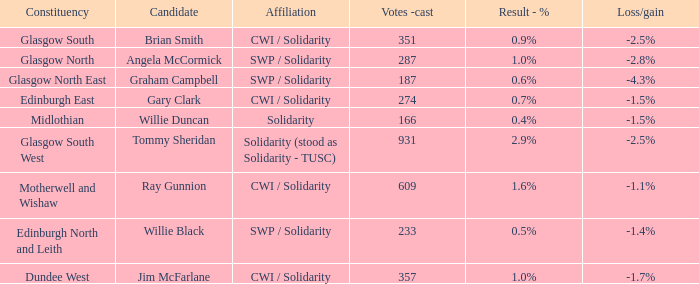Who was the candidate when the result - % was 0.4%? Willie Duncan. 